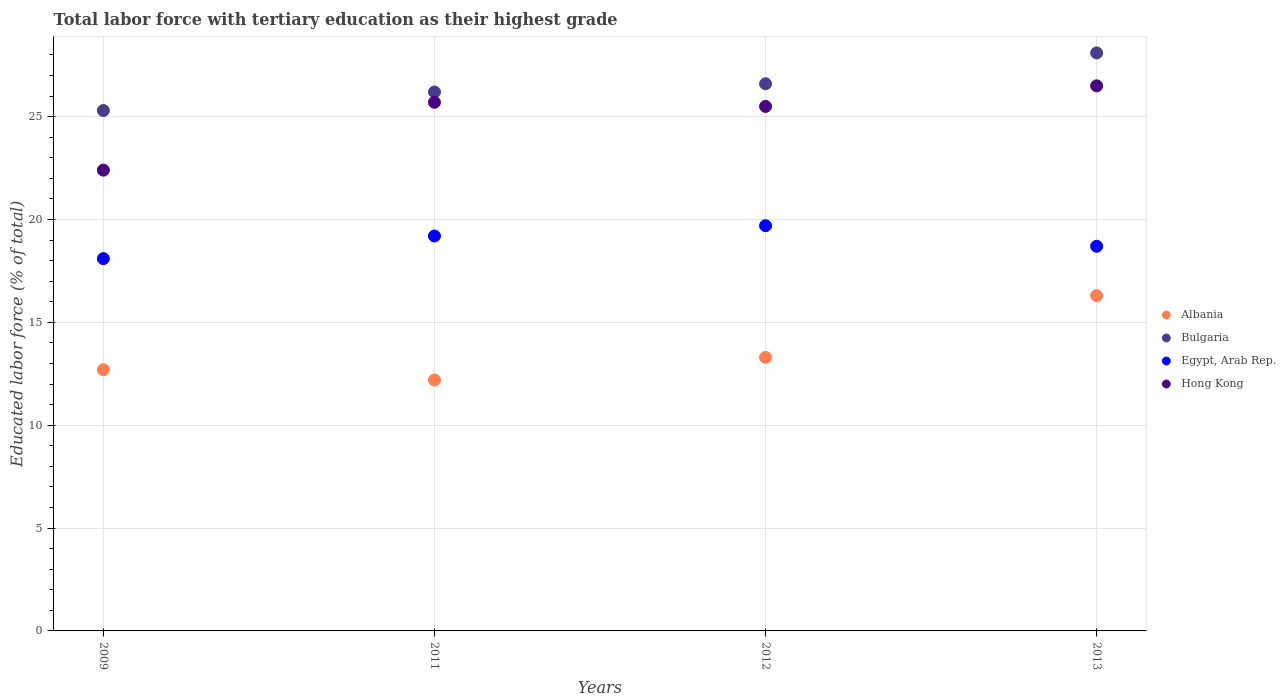What is the percentage of male labor force with tertiary education in Egypt, Arab Rep. in 2011?
Your answer should be very brief. 19.2. Across all years, what is the maximum percentage of male labor force with tertiary education in Albania?
Ensure brevity in your answer.  16.3. Across all years, what is the minimum percentage of male labor force with tertiary education in Albania?
Your answer should be compact. 12.2. What is the total percentage of male labor force with tertiary education in Bulgaria in the graph?
Your answer should be compact. 106.2. What is the difference between the percentage of male labor force with tertiary education in Hong Kong in 2012 and that in 2013?
Offer a very short reply. -1. What is the difference between the percentage of male labor force with tertiary education in Bulgaria in 2013 and the percentage of male labor force with tertiary education in Albania in 2012?
Ensure brevity in your answer.  14.8. What is the average percentage of male labor force with tertiary education in Albania per year?
Offer a very short reply. 13.62. In the year 2009, what is the difference between the percentage of male labor force with tertiary education in Bulgaria and percentage of male labor force with tertiary education in Egypt, Arab Rep.?
Offer a terse response. 7.2. What is the ratio of the percentage of male labor force with tertiary education in Hong Kong in 2011 to that in 2012?
Ensure brevity in your answer.  1.01. Is the percentage of male labor force with tertiary education in Hong Kong in 2009 less than that in 2012?
Offer a terse response. Yes. Is the difference between the percentage of male labor force with tertiary education in Bulgaria in 2011 and 2012 greater than the difference between the percentage of male labor force with tertiary education in Egypt, Arab Rep. in 2011 and 2012?
Give a very brief answer. Yes. What is the difference between the highest and the lowest percentage of male labor force with tertiary education in Albania?
Give a very brief answer. 4.1. Is the sum of the percentage of male labor force with tertiary education in Hong Kong in 2009 and 2011 greater than the maximum percentage of male labor force with tertiary education in Egypt, Arab Rep. across all years?
Provide a succinct answer. Yes. Is it the case that in every year, the sum of the percentage of male labor force with tertiary education in Egypt, Arab Rep. and percentage of male labor force with tertiary education in Hong Kong  is greater than the sum of percentage of male labor force with tertiary education in Bulgaria and percentage of male labor force with tertiary education in Albania?
Provide a short and direct response. Yes. How many dotlines are there?
Your response must be concise. 4. How many years are there in the graph?
Give a very brief answer. 4. Are the values on the major ticks of Y-axis written in scientific E-notation?
Your answer should be compact. No. Does the graph contain grids?
Keep it short and to the point. Yes. How are the legend labels stacked?
Your response must be concise. Vertical. What is the title of the graph?
Give a very brief answer. Total labor force with tertiary education as their highest grade. What is the label or title of the Y-axis?
Offer a terse response. Educated labor force (% of total). What is the Educated labor force (% of total) in Albania in 2009?
Offer a terse response. 12.7. What is the Educated labor force (% of total) in Bulgaria in 2009?
Provide a short and direct response. 25.3. What is the Educated labor force (% of total) of Egypt, Arab Rep. in 2009?
Ensure brevity in your answer.  18.1. What is the Educated labor force (% of total) in Hong Kong in 2009?
Your response must be concise. 22.4. What is the Educated labor force (% of total) of Albania in 2011?
Ensure brevity in your answer.  12.2. What is the Educated labor force (% of total) of Bulgaria in 2011?
Provide a short and direct response. 26.2. What is the Educated labor force (% of total) in Egypt, Arab Rep. in 2011?
Ensure brevity in your answer.  19.2. What is the Educated labor force (% of total) in Hong Kong in 2011?
Keep it short and to the point. 25.7. What is the Educated labor force (% of total) in Albania in 2012?
Keep it short and to the point. 13.3. What is the Educated labor force (% of total) in Bulgaria in 2012?
Offer a very short reply. 26.6. What is the Educated labor force (% of total) of Egypt, Arab Rep. in 2012?
Make the answer very short. 19.7. What is the Educated labor force (% of total) in Albania in 2013?
Offer a terse response. 16.3. What is the Educated labor force (% of total) in Bulgaria in 2013?
Provide a succinct answer. 28.1. What is the Educated labor force (% of total) in Egypt, Arab Rep. in 2013?
Your response must be concise. 18.7. Across all years, what is the maximum Educated labor force (% of total) in Albania?
Keep it short and to the point. 16.3. Across all years, what is the maximum Educated labor force (% of total) of Bulgaria?
Keep it short and to the point. 28.1. Across all years, what is the maximum Educated labor force (% of total) of Egypt, Arab Rep.?
Give a very brief answer. 19.7. Across all years, what is the minimum Educated labor force (% of total) in Albania?
Your response must be concise. 12.2. Across all years, what is the minimum Educated labor force (% of total) of Bulgaria?
Ensure brevity in your answer.  25.3. Across all years, what is the minimum Educated labor force (% of total) in Egypt, Arab Rep.?
Your answer should be compact. 18.1. Across all years, what is the minimum Educated labor force (% of total) of Hong Kong?
Offer a very short reply. 22.4. What is the total Educated labor force (% of total) in Albania in the graph?
Your answer should be very brief. 54.5. What is the total Educated labor force (% of total) in Bulgaria in the graph?
Give a very brief answer. 106.2. What is the total Educated labor force (% of total) in Egypt, Arab Rep. in the graph?
Keep it short and to the point. 75.7. What is the total Educated labor force (% of total) of Hong Kong in the graph?
Provide a succinct answer. 100.1. What is the difference between the Educated labor force (% of total) in Albania in 2009 and that in 2011?
Make the answer very short. 0.5. What is the difference between the Educated labor force (% of total) in Bulgaria in 2009 and that in 2011?
Give a very brief answer. -0.9. What is the difference between the Educated labor force (% of total) of Hong Kong in 2009 and that in 2012?
Keep it short and to the point. -3.1. What is the difference between the Educated labor force (% of total) of Albania in 2009 and that in 2013?
Your answer should be compact. -3.6. What is the difference between the Educated labor force (% of total) in Bulgaria in 2009 and that in 2013?
Keep it short and to the point. -2.8. What is the difference between the Educated labor force (% of total) of Albania in 2011 and that in 2012?
Offer a terse response. -1.1. What is the difference between the Educated labor force (% of total) in Bulgaria in 2011 and that in 2012?
Give a very brief answer. -0.4. What is the difference between the Educated labor force (% of total) in Egypt, Arab Rep. in 2011 and that in 2012?
Your answer should be very brief. -0.5. What is the difference between the Educated labor force (% of total) in Hong Kong in 2011 and that in 2012?
Your answer should be very brief. 0.2. What is the difference between the Educated labor force (% of total) of Albania in 2011 and that in 2013?
Offer a terse response. -4.1. What is the difference between the Educated labor force (% of total) in Bulgaria in 2011 and that in 2013?
Your response must be concise. -1.9. What is the difference between the Educated labor force (% of total) in Hong Kong in 2011 and that in 2013?
Provide a succinct answer. -0.8. What is the difference between the Educated labor force (% of total) of Bulgaria in 2012 and that in 2013?
Your answer should be compact. -1.5. What is the difference between the Educated labor force (% of total) in Albania in 2009 and the Educated labor force (% of total) in Bulgaria in 2011?
Keep it short and to the point. -13.5. What is the difference between the Educated labor force (% of total) in Albania in 2009 and the Educated labor force (% of total) in Egypt, Arab Rep. in 2011?
Provide a succinct answer. -6.5. What is the difference between the Educated labor force (% of total) in Albania in 2009 and the Educated labor force (% of total) in Hong Kong in 2011?
Offer a very short reply. -13. What is the difference between the Educated labor force (% of total) of Bulgaria in 2009 and the Educated labor force (% of total) of Hong Kong in 2011?
Your response must be concise. -0.4. What is the difference between the Educated labor force (% of total) of Egypt, Arab Rep. in 2009 and the Educated labor force (% of total) of Hong Kong in 2011?
Ensure brevity in your answer.  -7.6. What is the difference between the Educated labor force (% of total) in Albania in 2009 and the Educated labor force (% of total) in Bulgaria in 2012?
Your answer should be very brief. -13.9. What is the difference between the Educated labor force (% of total) of Albania in 2009 and the Educated labor force (% of total) of Egypt, Arab Rep. in 2012?
Give a very brief answer. -7. What is the difference between the Educated labor force (% of total) of Albania in 2009 and the Educated labor force (% of total) of Hong Kong in 2012?
Your answer should be very brief. -12.8. What is the difference between the Educated labor force (% of total) of Bulgaria in 2009 and the Educated labor force (% of total) of Hong Kong in 2012?
Keep it short and to the point. -0.2. What is the difference between the Educated labor force (% of total) of Albania in 2009 and the Educated labor force (% of total) of Bulgaria in 2013?
Offer a very short reply. -15.4. What is the difference between the Educated labor force (% of total) of Albania in 2009 and the Educated labor force (% of total) of Egypt, Arab Rep. in 2013?
Keep it short and to the point. -6. What is the difference between the Educated labor force (% of total) in Albania in 2009 and the Educated labor force (% of total) in Hong Kong in 2013?
Make the answer very short. -13.8. What is the difference between the Educated labor force (% of total) of Egypt, Arab Rep. in 2009 and the Educated labor force (% of total) of Hong Kong in 2013?
Make the answer very short. -8.4. What is the difference between the Educated labor force (% of total) in Albania in 2011 and the Educated labor force (% of total) in Bulgaria in 2012?
Keep it short and to the point. -14.4. What is the difference between the Educated labor force (% of total) of Bulgaria in 2011 and the Educated labor force (% of total) of Egypt, Arab Rep. in 2012?
Your answer should be compact. 6.5. What is the difference between the Educated labor force (% of total) of Albania in 2011 and the Educated labor force (% of total) of Bulgaria in 2013?
Make the answer very short. -15.9. What is the difference between the Educated labor force (% of total) in Albania in 2011 and the Educated labor force (% of total) in Hong Kong in 2013?
Keep it short and to the point. -14.3. What is the difference between the Educated labor force (% of total) in Egypt, Arab Rep. in 2011 and the Educated labor force (% of total) in Hong Kong in 2013?
Keep it short and to the point. -7.3. What is the difference between the Educated labor force (% of total) in Albania in 2012 and the Educated labor force (% of total) in Bulgaria in 2013?
Provide a short and direct response. -14.8. What is the difference between the Educated labor force (% of total) of Albania in 2012 and the Educated labor force (% of total) of Hong Kong in 2013?
Offer a very short reply. -13.2. What is the difference between the Educated labor force (% of total) of Egypt, Arab Rep. in 2012 and the Educated labor force (% of total) of Hong Kong in 2013?
Offer a very short reply. -6.8. What is the average Educated labor force (% of total) in Albania per year?
Provide a short and direct response. 13.62. What is the average Educated labor force (% of total) in Bulgaria per year?
Give a very brief answer. 26.55. What is the average Educated labor force (% of total) of Egypt, Arab Rep. per year?
Offer a terse response. 18.93. What is the average Educated labor force (% of total) in Hong Kong per year?
Your response must be concise. 25.02. In the year 2009, what is the difference between the Educated labor force (% of total) in Albania and Educated labor force (% of total) in Bulgaria?
Keep it short and to the point. -12.6. In the year 2009, what is the difference between the Educated labor force (% of total) in Albania and Educated labor force (% of total) in Egypt, Arab Rep.?
Offer a terse response. -5.4. In the year 2009, what is the difference between the Educated labor force (% of total) in Bulgaria and Educated labor force (% of total) in Egypt, Arab Rep.?
Your answer should be very brief. 7.2. In the year 2009, what is the difference between the Educated labor force (% of total) in Egypt, Arab Rep. and Educated labor force (% of total) in Hong Kong?
Keep it short and to the point. -4.3. In the year 2011, what is the difference between the Educated labor force (% of total) of Albania and Educated labor force (% of total) of Bulgaria?
Your answer should be very brief. -14. In the year 2011, what is the difference between the Educated labor force (% of total) of Egypt, Arab Rep. and Educated labor force (% of total) of Hong Kong?
Give a very brief answer. -6.5. In the year 2012, what is the difference between the Educated labor force (% of total) of Albania and Educated labor force (% of total) of Egypt, Arab Rep.?
Offer a terse response. -6.4. In the year 2012, what is the difference between the Educated labor force (% of total) in Egypt, Arab Rep. and Educated labor force (% of total) in Hong Kong?
Offer a very short reply. -5.8. In the year 2013, what is the difference between the Educated labor force (% of total) in Albania and Educated labor force (% of total) in Egypt, Arab Rep.?
Provide a succinct answer. -2.4. In the year 2013, what is the difference between the Educated labor force (% of total) in Albania and Educated labor force (% of total) in Hong Kong?
Give a very brief answer. -10.2. In the year 2013, what is the difference between the Educated labor force (% of total) of Bulgaria and Educated labor force (% of total) of Hong Kong?
Offer a terse response. 1.6. What is the ratio of the Educated labor force (% of total) of Albania in 2009 to that in 2011?
Your answer should be very brief. 1.04. What is the ratio of the Educated labor force (% of total) in Bulgaria in 2009 to that in 2011?
Give a very brief answer. 0.97. What is the ratio of the Educated labor force (% of total) in Egypt, Arab Rep. in 2009 to that in 2011?
Offer a very short reply. 0.94. What is the ratio of the Educated labor force (% of total) in Hong Kong in 2009 to that in 2011?
Your answer should be compact. 0.87. What is the ratio of the Educated labor force (% of total) of Albania in 2009 to that in 2012?
Your answer should be very brief. 0.95. What is the ratio of the Educated labor force (% of total) of Bulgaria in 2009 to that in 2012?
Make the answer very short. 0.95. What is the ratio of the Educated labor force (% of total) in Egypt, Arab Rep. in 2009 to that in 2012?
Offer a terse response. 0.92. What is the ratio of the Educated labor force (% of total) of Hong Kong in 2009 to that in 2012?
Your answer should be very brief. 0.88. What is the ratio of the Educated labor force (% of total) of Albania in 2009 to that in 2013?
Give a very brief answer. 0.78. What is the ratio of the Educated labor force (% of total) of Bulgaria in 2009 to that in 2013?
Provide a short and direct response. 0.9. What is the ratio of the Educated labor force (% of total) in Egypt, Arab Rep. in 2009 to that in 2013?
Give a very brief answer. 0.97. What is the ratio of the Educated labor force (% of total) of Hong Kong in 2009 to that in 2013?
Your answer should be very brief. 0.85. What is the ratio of the Educated labor force (% of total) in Albania in 2011 to that in 2012?
Make the answer very short. 0.92. What is the ratio of the Educated labor force (% of total) in Egypt, Arab Rep. in 2011 to that in 2012?
Provide a succinct answer. 0.97. What is the ratio of the Educated labor force (% of total) of Hong Kong in 2011 to that in 2012?
Provide a short and direct response. 1.01. What is the ratio of the Educated labor force (% of total) in Albania in 2011 to that in 2013?
Provide a succinct answer. 0.75. What is the ratio of the Educated labor force (% of total) in Bulgaria in 2011 to that in 2013?
Give a very brief answer. 0.93. What is the ratio of the Educated labor force (% of total) of Egypt, Arab Rep. in 2011 to that in 2013?
Offer a very short reply. 1.03. What is the ratio of the Educated labor force (% of total) in Hong Kong in 2011 to that in 2013?
Make the answer very short. 0.97. What is the ratio of the Educated labor force (% of total) in Albania in 2012 to that in 2013?
Your answer should be very brief. 0.82. What is the ratio of the Educated labor force (% of total) in Bulgaria in 2012 to that in 2013?
Your answer should be very brief. 0.95. What is the ratio of the Educated labor force (% of total) in Egypt, Arab Rep. in 2012 to that in 2013?
Your answer should be compact. 1.05. What is the ratio of the Educated labor force (% of total) in Hong Kong in 2012 to that in 2013?
Keep it short and to the point. 0.96. What is the difference between the highest and the second highest Educated labor force (% of total) in Bulgaria?
Your answer should be very brief. 1.5. What is the difference between the highest and the second highest Educated labor force (% of total) of Egypt, Arab Rep.?
Your response must be concise. 0.5. What is the difference between the highest and the lowest Educated labor force (% of total) in Hong Kong?
Offer a very short reply. 4.1. 